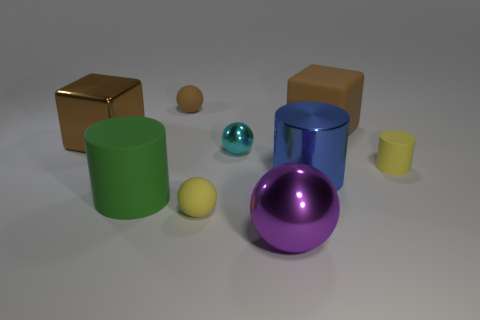Subtract all rubber cylinders. How many cylinders are left? 1 Subtract 2 balls. How many balls are left? 2 Add 1 small green matte objects. How many objects exist? 10 Subtract all gray balls. Subtract all red cubes. How many balls are left? 4 Subtract all blocks. How many objects are left? 7 Subtract 0 yellow cubes. How many objects are left? 9 Subtract all green things. Subtract all brown things. How many objects are left? 5 Add 5 large brown shiny things. How many large brown shiny things are left? 6 Add 6 green cylinders. How many green cylinders exist? 7 